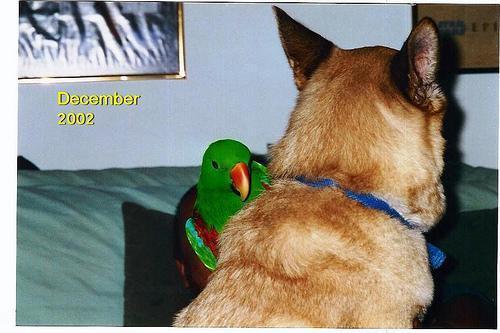How many animals are there?
Give a very brief answer. 2. How many beds are in the picture?
Give a very brief answer. 1. 